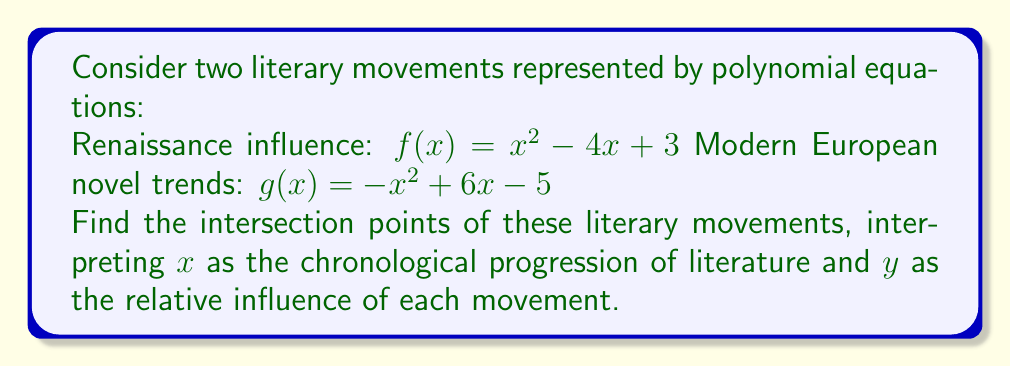Solve this math problem. To find the intersection points, we need to solve the system of equations:

$$f(x) = g(x)$$
$$x^2 - 4x + 3 = -x^2 + 6x - 5$$

Step 1: Rearrange the equation to standard form
$$x^2 - 4x + 3 = -x^2 + 6x - 5$$
$$x^2 + (-x^2) = 6x - 4x + (-5 - 3)$$
$$2x^2 = 2x - 8$$

Step 2: Move all terms to one side
$$2x^2 - 2x + 8 = 0$$

Step 3: Divide all terms by 2 to simplify
$$x^2 - x + 4 = 0$$

Step 4: Use the quadratic formula to solve
$x = \frac{-b \pm \sqrt{b^2 - 4ac}}{2a}$, where $a=1$, $b=-1$, and $c=4$

$$x = \frac{1 \pm \sqrt{1 - 16}}{2} = \frac{1 \pm \sqrt{-15}}{2}$$

Step 5: Simplify the result
Since $\sqrt{-15}$ is imaginary, we can express it as $i\sqrt{15}$

$$x = \frac{1 \pm i\sqrt{15}}{2}$$

Step 6: Calculate the y-coordinate using either $f(x)$ or $g(x)$
Let's use $f(x) = x^2 - 4x + 3$

$$y = (\frac{1 \pm i\sqrt{15}}{2})^2 - 4(\frac{1 \pm i\sqrt{15}}{2}) + 3$$

Simplifying this complex expression gives:

$$y = \frac{-13 \mp i\sqrt{15}}{4}$$

Therefore, the intersection points are:

$$(\frac{1 + i\sqrt{15}}{2}, \frac{-13 - i\sqrt{15}}{4}) \text{ and } (\frac{1 - i\sqrt{15}}{2}, \frac{-13 + i\sqrt{15}}{4})$$
Answer: $(\frac{1 + i\sqrt{15}}{2}, \frac{-13 - i\sqrt{15}}{4})$ and $(\frac{1 - i\sqrt{15}}{2}, \frac{-13 + i\sqrt{15}}{4})$ 